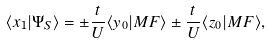Convert formula to latex. <formula><loc_0><loc_0><loc_500><loc_500>\langle x _ { 1 } | \Psi _ { S } \rangle = \pm \frac { t } { U } \langle y _ { 0 } | M F \rangle \pm \frac { t } { U } \langle z _ { 0 } | M F \rangle ,</formula> 